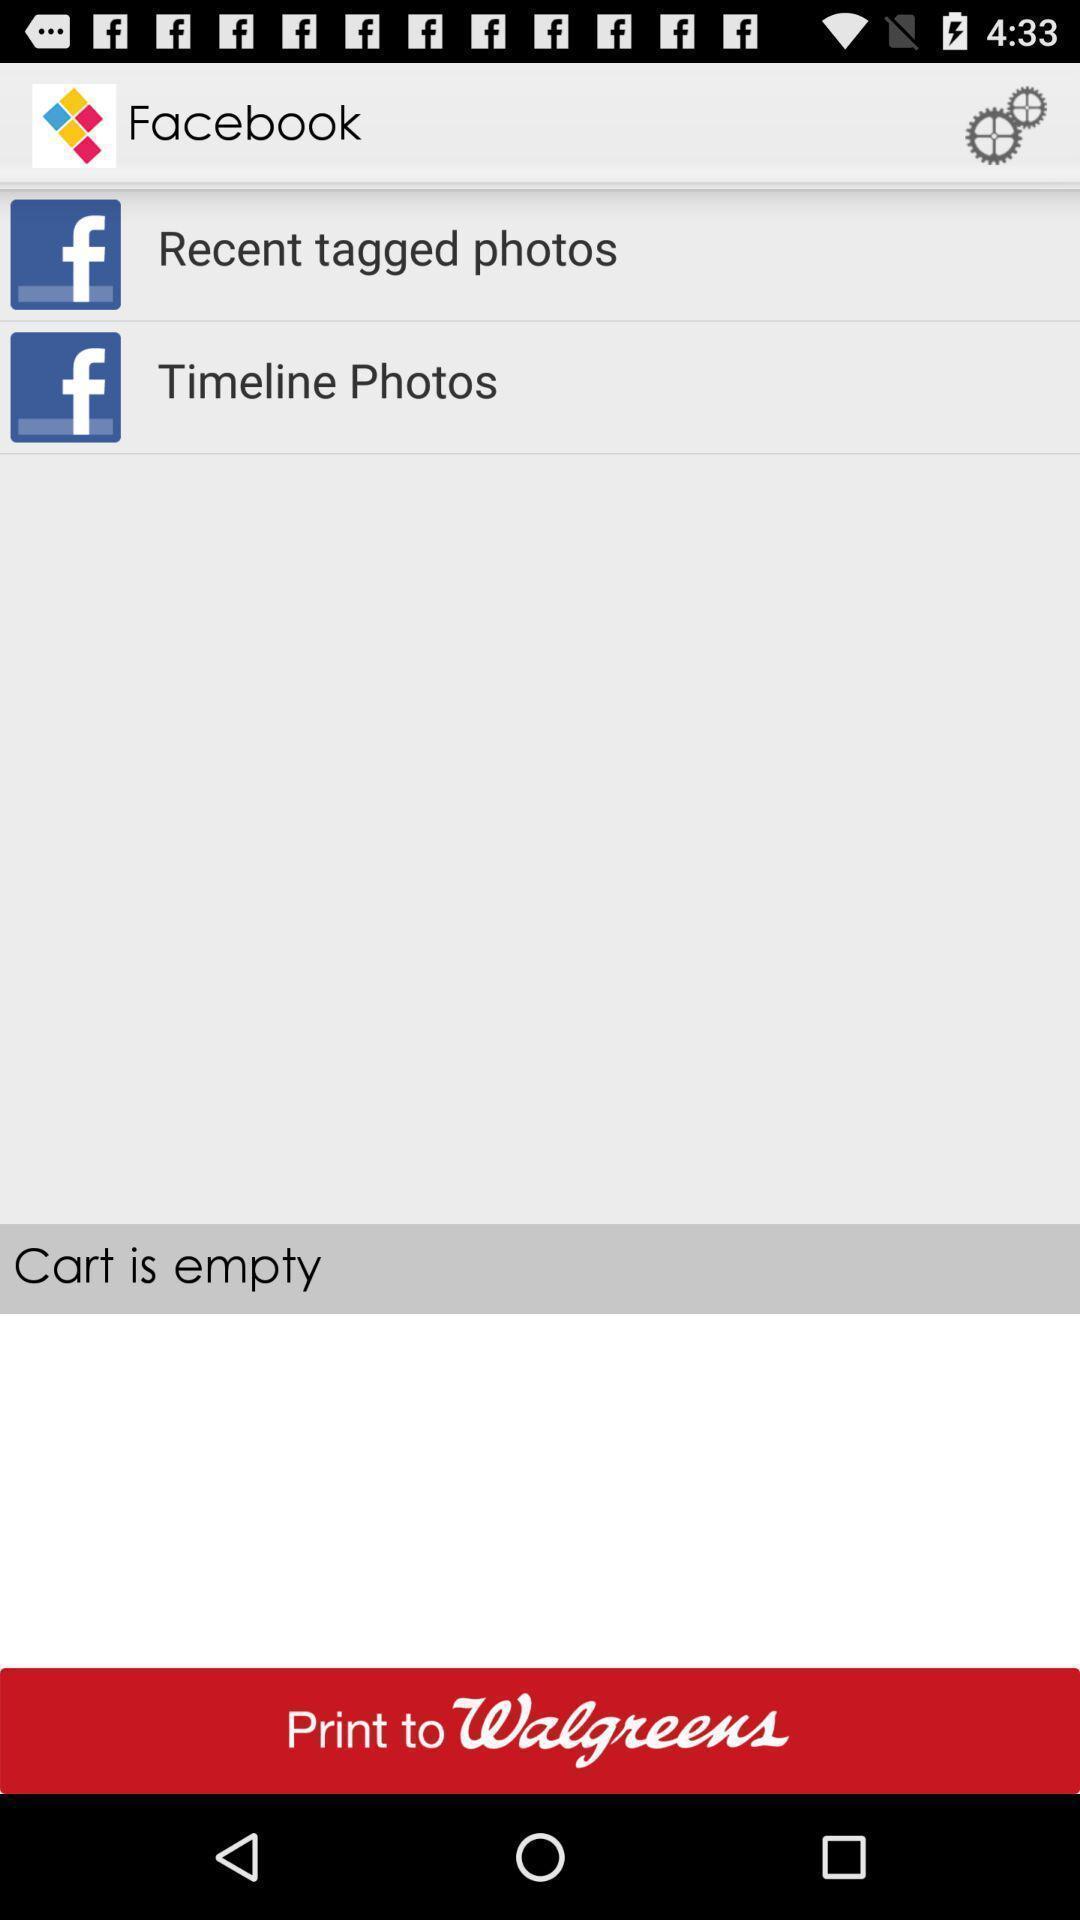Tell me what you see in this picture. Various categorized photo tabs in the social media. 